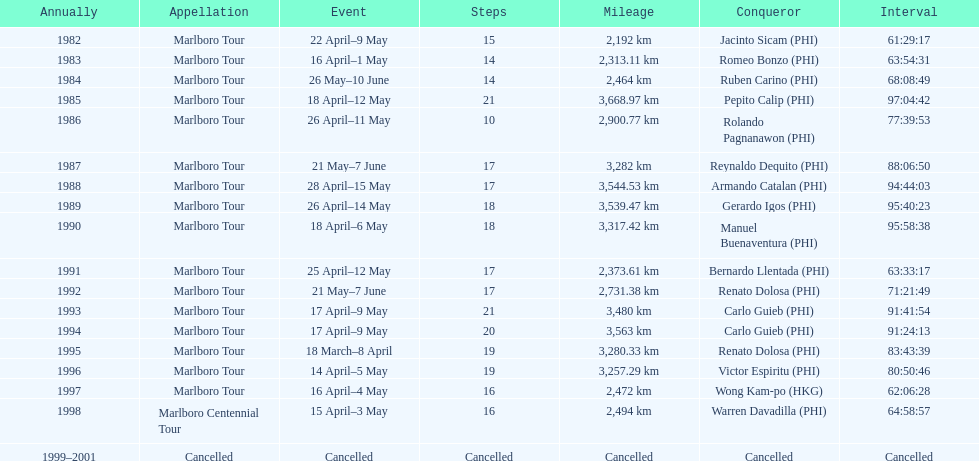What was the largest distance traveled for the marlboro tour? 3,668.97 km. 